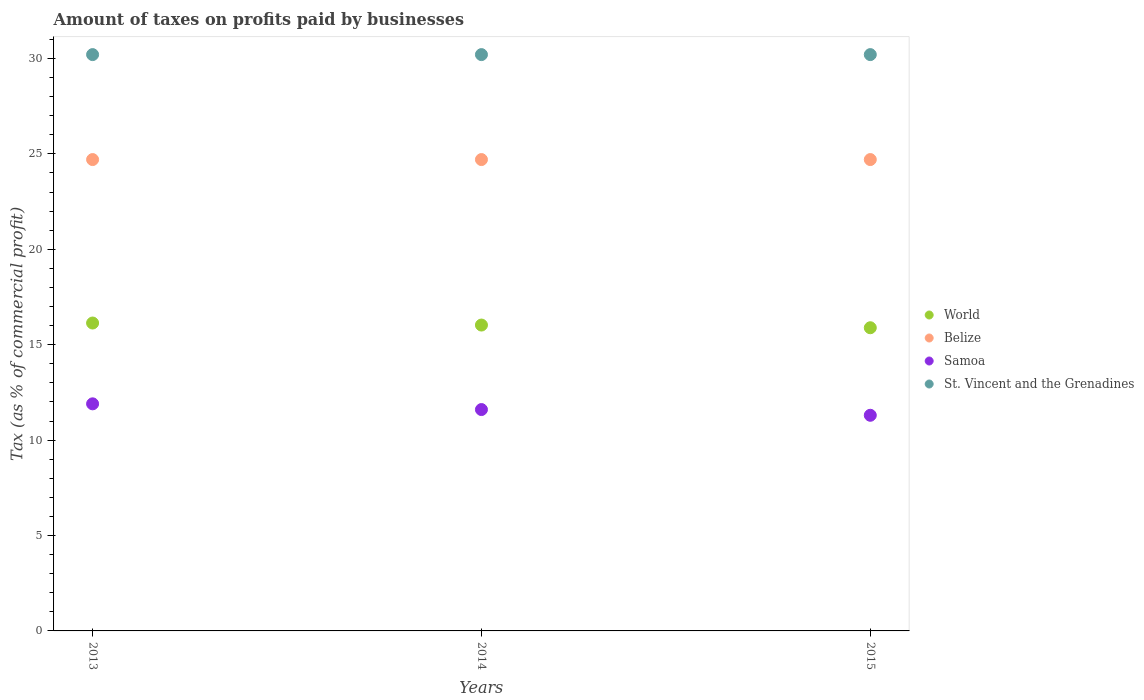What is the percentage of taxes paid by businesses in St. Vincent and the Grenadines in 2013?
Keep it short and to the point. 30.2. Across all years, what is the maximum percentage of taxes paid by businesses in World?
Ensure brevity in your answer.  16.13. Across all years, what is the minimum percentage of taxes paid by businesses in Belize?
Make the answer very short. 24.7. In which year was the percentage of taxes paid by businesses in Samoa maximum?
Ensure brevity in your answer.  2013. In which year was the percentage of taxes paid by businesses in Samoa minimum?
Provide a short and direct response. 2015. What is the total percentage of taxes paid by businesses in St. Vincent and the Grenadines in the graph?
Make the answer very short. 90.6. What is the difference between the percentage of taxes paid by businesses in Belize in 2013 and the percentage of taxes paid by businesses in World in 2014?
Offer a very short reply. 8.67. What is the average percentage of taxes paid by businesses in Samoa per year?
Make the answer very short. 11.6. In the year 2015, what is the difference between the percentage of taxes paid by businesses in World and percentage of taxes paid by businesses in Belize?
Provide a succinct answer. -8.81. What is the ratio of the percentage of taxes paid by businesses in Samoa in 2013 to that in 2015?
Your answer should be compact. 1.05. Is the percentage of taxes paid by businesses in World in 2014 less than that in 2015?
Make the answer very short. No. What is the difference between the highest and the second highest percentage of taxes paid by businesses in Samoa?
Provide a short and direct response. 0.3. In how many years, is the percentage of taxes paid by businesses in Belize greater than the average percentage of taxes paid by businesses in Belize taken over all years?
Provide a succinct answer. 0. Is the sum of the percentage of taxes paid by businesses in Belize in 2013 and 2015 greater than the maximum percentage of taxes paid by businesses in St. Vincent and the Grenadines across all years?
Provide a short and direct response. Yes. Is it the case that in every year, the sum of the percentage of taxes paid by businesses in St. Vincent and the Grenadines and percentage of taxes paid by businesses in Belize  is greater than the percentage of taxes paid by businesses in World?
Make the answer very short. Yes. Does the percentage of taxes paid by businesses in St. Vincent and the Grenadines monotonically increase over the years?
Your response must be concise. No. How many years are there in the graph?
Make the answer very short. 3. What is the difference between two consecutive major ticks on the Y-axis?
Ensure brevity in your answer.  5. Are the values on the major ticks of Y-axis written in scientific E-notation?
Provide a succinct answer. No. Does the graph contain grids?
Ensure brevity in your answer.  No. How many legend labels are there?
Give a very brief answer. 4. How are the legend labels stacked?
Keep it short and to the point. Vertical. What is the title of the graph?
Your answer should be very brief. Amount of taxes on profits paid by businesses. What is the label or title of the X-axis?
Provide a short and direct response. Years. What is the label or title of the Y-axis?
Ensure brevity in your answer.  Tax (as % of commercial profit). What is the Tax (as % of commercial profit) in World in 2013?
Your answer should be compact. 16.13. What is the Tax (as % of commercial profit) of Belize in 2013?
Offer a very short reply. 24.7. What is the Tax (as % of commercial profit) of St. Vincent and the Grenadines in 2013?
Make the answer very short. 30.2. What is the Tax (as % of commercial profit) in World in 2014?
Ensure brevity in your answer.  16.03. What is the Tax (as % of commercial profit) in Belize in 2014?
Offer a terse response. 24.7. What is the Tax (as % of commercial profit) of St. Vincent and the Grenadines in 2014?
Offer a very short reply. 30.2. What is the Tax (as % of commercial profit) in World in 2015?
Offer a terse response. 15.89. What is the Tax (as % of commercial profit) of Belize in 2015?
Provide a short and direct response. 24.7. What is the Tax (as % of commercial profit) of Samoa in 2015?
Offer a terse response. 11.3. What is the Tax (as % of commercial profit) in St. Vincent and the Grenadines in 2015?
Offer a terse response. 30.2. Across all years, what is the maximum Tax (as % of commercial profit) in World?
Ensure brevity in your answer.  16.13. Across all years, what is the maximum Tax (as % of commercial profit) of Belize?
Your answer should be very brief. 24.7. Across all years, what is the maximum Tax (as % of commercial profit) of Samoa?
Your answer should be compact. 11.9. Across all years, what is the maximum Tax (as % of commercial profit) of St. Vincent and the Grenadines?
Keep it short and to the point. 30.2. Across all years, what is the minimum Tax (as % of commercial profit) of World?
Offer a terse response. 15.89. Across all years, what is the minimum Tax (as % of commercial profit) of Belize?
Provide a succinct answer. 24.7. Across all years, what is the minimum Tax (as % of commercial profit) in St. Vincent and the Grenadines?
Your answer should be very brief. 30.2. What is the total Tax (as % of commercial profit) in World in the graph?
Your response must be concise. 48.05. What is the total Tax (as % of commercial profit) of Belize in the graph?
Give a very brief answer. 74.1. What is the total Tax (as % of commercial profit) of Samoa in the graph?
Keep it short and to the point. 34.8. What is the total Tax (as % of commercial profit) in St. Vincent and the Grenadines in the graph?
Offer a terse response. 90.6. What is the difference between the Tax (as % of commercial profit) in World in 2013 and that in 2014?
Your response must be concise. 0.11. What is the difference between the Tax (as % of commercial profit) in Belize in 2013 and that in 2014?
Your answer should be very brief. 0. What is the difference between the Tax (as % of commercial profit) in Samoa in 2013 and that in 2014?
Your answer should be very brief. 0.3. What is the difference between the Tax (as % of commercial profit) in World in 2013 and that in 2015?
Offer a terse response. 0.25. What is the difference between the Tax (as % of commercial profit) in St. Vincent and the Grenadines in 2013 and that in 2015?
Make the answer very short. 0. What is the difference between the Tax (as % of commercial profit) of World in 2014 and that in 2015?
Provide a succinct answer. 0.14. What is the difference between the Tax (as % of commercial profit) in Belize in 2014 and that in 2015?
Provide a short and direct response. 0. What is the difference between the Tax (as % of commercial profit) in Samoa in 2014 and that in 2015?
Offer a very short reply. 0.3. What is the difference between the Tax (as % of commercial profit) of St. Vincent and the Grenadines in 2014 and that in 2015?
Make the answer very short. 0. What is the difference between the Tax (as % of commercial profit) of World in 2013 and the Tax (as % of commercial profit) of Belize in 2014?
Offer a very short reply. -8.57. What is the difference between the Tax (as % of commercial profit) in World in 2013 and the Tax (as % of commercial profit) in Samoa in 2014?
Offer a terse response. 4.53. What is the difference between the Tax (as % of commercial profit) of World in 2013 and the Tax (as % of commercial profit) of St. Vincent and the Grenadines in 2014?
Keep it short and to the point. -14.07. What is the difference between the Tax (as % of commercial profit) in Belize in 2013 and the Tax (as % of commercial profit) in Samoa in 2014?
Your answer should be compact. 13.1. What is the difference between the Tax (as % of commercial profit) in Belize in 2013 and the Tax (as % of commercial profit) in St. Vincent and the Grenadines in 2014?
Offer a very short reply. -5.5. What is the difference between the Tax (as % of commercial profit) in Samoa in 2013 and the Tax (as % of commercial profit) in St. Vincent and the Grenadines in 2014?
Give a very brief answer. -18.3. What is the difference between the Tax (as % of commercial profit) in World in 2013 and the Tax (as % of commercial profit) in Belize in 2015?
Give a very brief answer. -8.57. What is the difference between the Tax (as % of commercial profit) in World in 2013 and the Tax (as % of commercial profit) in Samoa in 2015?
Give a very brief answer. 4.83. What is the difference between the Tax (as % of commercial profit) of World in 2013 and the Tax (as % of commercial profit) of St. Vincent and the Grenadines in 2015?
Provide a short and direct response. -14.07. What is the difference between the Tax (as % of commercial profit) in Samoa in 2013 and the Tax (as % of commercial profit) in St. Vincent and the Grenadines in 2015?
Offer a very short reply. -18.3. What is the difference between the Tax (as % of commercial profit) of World in 2014 and the Tax (as % of commercial profit) of Belize in 2015?
Provide a succinct answer. -8.67. What is the difference between the Tax (as % of commercial profit) in World in 2014 and the Tax (as % of commercial profit) in Samoa in 2015?
Your answer should be very brief. 4.73. What is the difference between the Tax (as % of commercial profit) in World in 2014 and the Tax (as % of commercial profit) in St. Vincent and the Grenadines in 2015?
Make the answer very short. -14.17. What is the difference between the Tax (as % of commercial profit) of Belize in 2014 and the Tax (as % of commercial profit) of St. Vincent and the Grenadines in 2015?
Make the answer very short. -5.5. What is the difference between the Tax (as % of commercial profit) in Samoa in 2014 and the Tax (as % of commercial profit) in St. Vincent and the Grenadines in 2015?
Provide a succinct answer. -18.6. What is the average Tax (as % of commercial profit) of World per year?
Your answer should be compact. 16.02. What is the average Tax (as % of commercial profit) in Belize per year?
Provide a short and direct response. 24.7. What is the average Tax (as % of commercial profit) in Samoa per year?
Ensure brevity in your answer.  11.6. What is the average Tax (as % of commercial profit) in St. Vincent and the Grenadines per year?
Ensure brevity in your answer.  30.2. In the year 2013, what is the difference between the Tax (as % of commercial profit) of World and Tax (as % of commercial profit) of Belize?
Keep it short and to the point. -8.57. In the year 2013, what is the difference between the Tax (as % of commercial profit) in World and Tax (as % of commercial profit) in Samoa?
Offer a very short reply. 4.23. In the year 2013, what is the difference between the Tax (as % of commercial profit) of World and Tax (as % of commercial profit) of St. Vincent and the Grenadines?
Your response must be concise. -14.07. In the year 2013, what is the difference between the Tax (as % of commercial profit) of Belize and Tax (as % of commercial profit) of Samoa?
Make the answer very short. 12.8. In the year 2013, what is the difference between the Tax (as % of commercial profit) of Samoa and Tax (as % of commercial profit) of St. Vincent and the Grenadines?
Offer a very short reply. -18.3. In the year 2014, what is the difference between the Tax (as % of commercial profit) in World and Tax (as % of commercial profit) in Belize?
Make the answer very short. -8.67. In the year 2014, what is the difference between the Tax (as % of commercial profit) of World and Tax (as % of commercial profit) of Samoa?
Your answer should be very brief. 4.43. In the year 2014, what is the difference between the Tax (as % of commercial profit) of World and Tax (as % of commercial profit) of St. Vincent and the Grenadines?
Your answer should be compact. -14.17. In the year 2014, what is the difference between the Tax (as % of commercial profit) of Belize and Tax (as % of commercial profit) of Samoa?
Keep it short and to the point. 13.1. In the year 2014, what is the difference between the Tax (as % of commercial profit) in Samoa and Tax (as % of commercial profit) in St. Vincent and the Grenadines?
Your response must be concise. -18.6. In the year 2015, what is the difference between the Tax (as % of commercial profit) in World and Tax (as % of commercial profit) in Belize?
Your response must be concise. -8.81. In the year 2015, what is the difference between the Tax (as % of commercial profit) in World and Tax (as % of commercial profit) in Samoa?
Provide a succinct answer. 4.59. In the year 2015, what is the difference between the Tax (as % of commercial profit) in World and Tax (as % of commercial profit) in St. Vincent and the Grenadines?
Your response must be concise. -14.31. In the year 2015, what is the difference between the Tax (as % of commercial profit) in Belize and Tax (as % of commercial profit) in Samoa?
Keep it short and to the point. 13.4. In the year 2015, what is the difference between the Tax (as % of commercial profit) in Samoa and Tax (as % of commercial profit) in St. Vincent and the Grenadines?
Provide a short and direct response. -18.9. What is the ratio of the Tax (as % of commercial profit) of World in 2013 to that in 2014?
Your response must be concise. 1.01. What is the ratio of the Tax (as % of commercial profit) in Samoa in 2013 to that in 2014?
Offer a terse response. 1.03. What is the ratio of the Tax (as % of commercial profit) of World in 2013 to that in 2015?
Provide a short and direct response. 1.02. What is the ratio of the Tax (as % of commercial profit) of Belize in 2013 to that in 2015?
Your answer should be compact. 1. What is the ratio of the Tax (as % of commercial profit) of Samoa in 2013 to that in 2015?
Provide a short and direct response. 1.05. What is the ratio of the Tax (as % of commercial profit) of St. Vincent and the Grenadines in 2013 to that in 2015?
Ensure brevity in your answer.  1. What is the ratio of the Tax (as % of commercial profit) in World in 2014 to that in 2015?
Offer a terse response. 1.01. What is the ratio of the Tax (as % of commercial profit) of Belize in 2014 to that in 2015?
Your answer should be compact. 1. What is the ratio of the Tax (as % of commercial profit) of Samoa in 2014 to that in 2015?
Provide a succinct answer. 1.03. What is the difference between the highest and the second highest Tax (as % of commercial profit) in World?
Keep it short and to the point. 0.11. What is the difference between the highest and the second highest Tax (as % of commercial profit) of Belize?
Keep it short and to the point. 0. What is the difference between the highest and the lowest Tax (as % of commercial profit) in World?
Your response must be concise. 0.25. What is the difference between the highest and the lowest Tax (as % of commercial profit) in Samoa?
Keep it short and to the point. 0.6. 